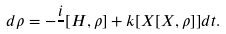<formula> <loc_0><loc_0><loc_500><loc_500>d \rho = - { \frac { i } { } [ H , \rho ] + k [ X [ X , \rho ] ] } d t .</formula> 